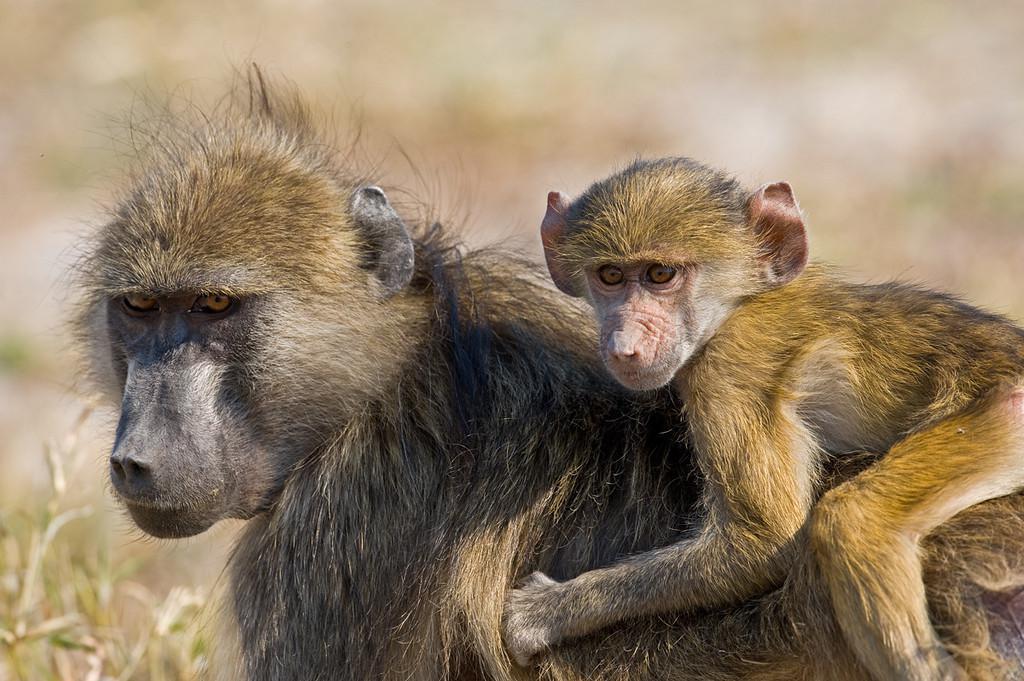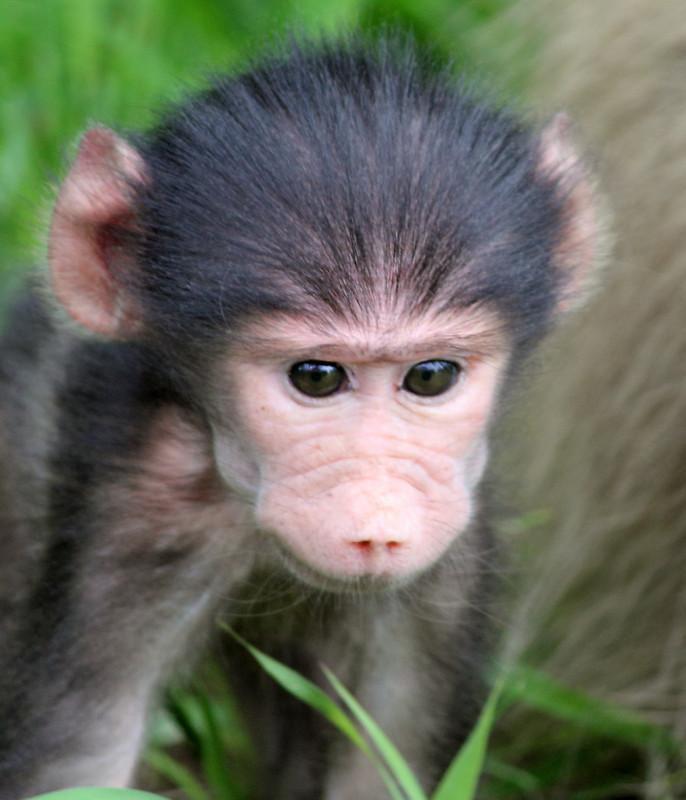The first image is the image on the left, the second image is the image on the right. Considering the images on both sides, is "There are three monkeys." valid? Answer yes or no. Yes. The first image is the image on the left, the second image is the image on the right. Considering the images on both sides, is "In the image on the left, a mother carries her baby." valid? Answer yes or no. Yes. 